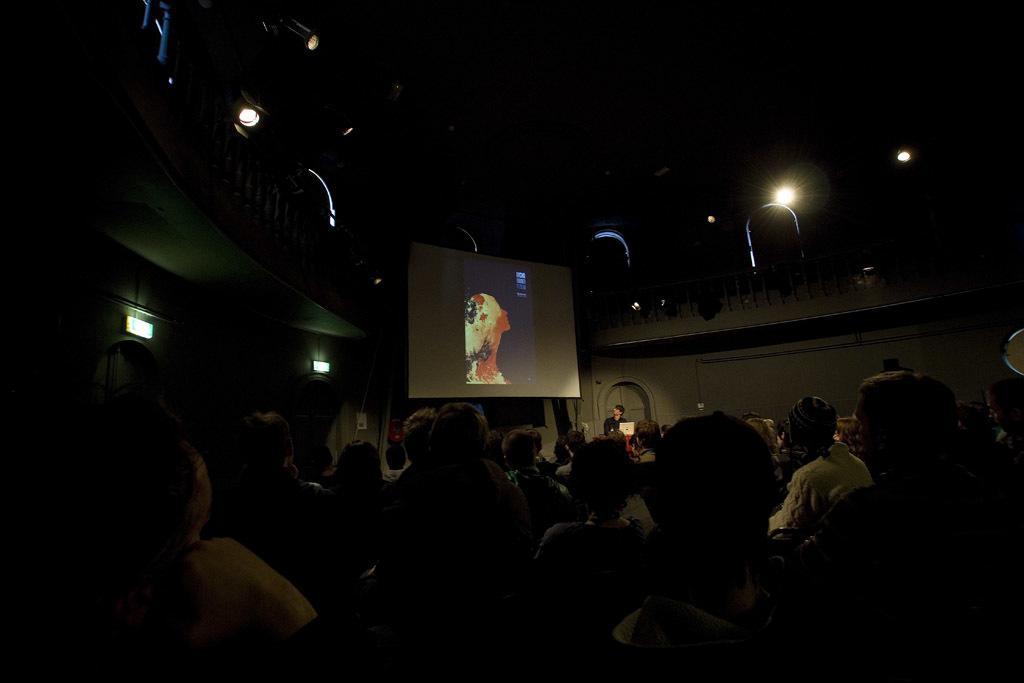Could you give a brief overview of what you see in this image? In this image I can see group of people sitting. In the background I can see the screen and I can also see few lights. 